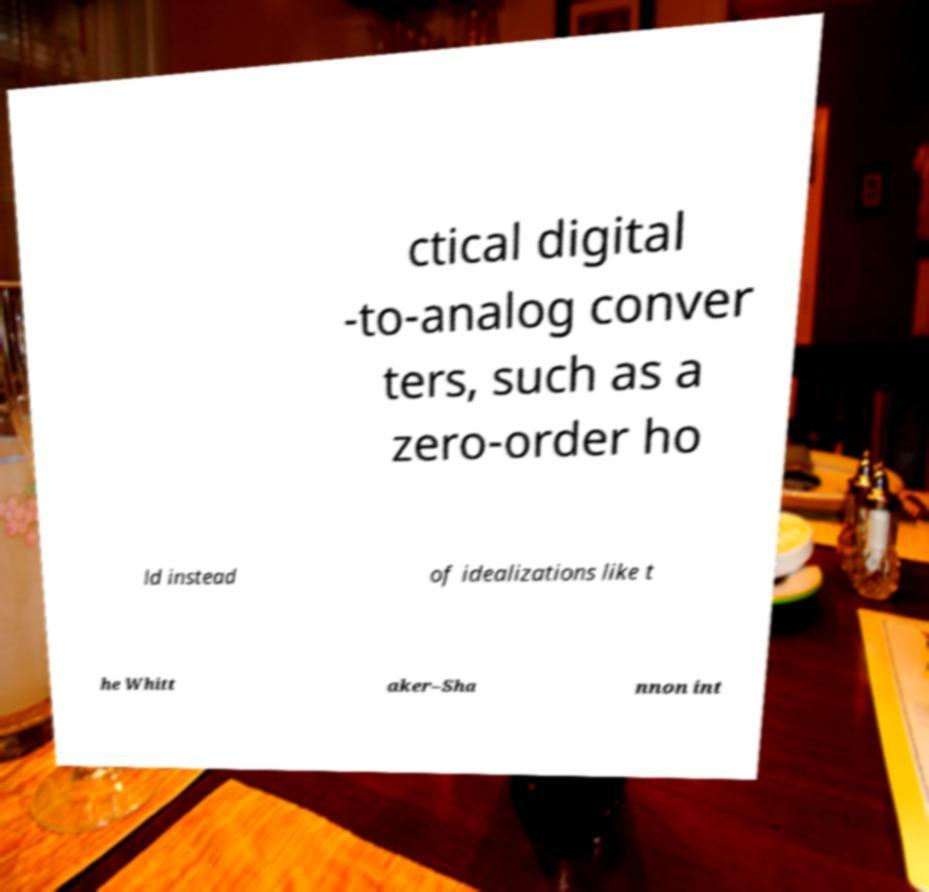Please identify and transcribe the text found in this image. ctical digital -to-analog conver ters, such as a zero-order ho ld instead of idealizations like t he Whitt aker–Sha nnon int 